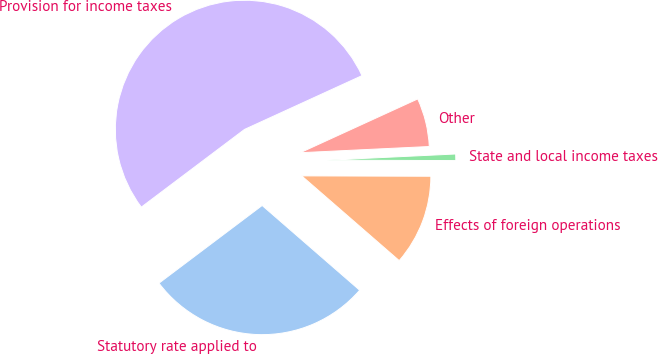Convert chart to OTSL. <chart><loc_0><loc_0><loc_500><loc_500><pie_chart><fcel>Statutory rate applied to<fcel>Effects of foreign operations<fcel>State and local income taxes<fcel>Other<fcel>Provision for income taxes<nl><fcel>28.34%<fcel>11.34%<fcel>0.81%<fcel>6.07%<fcel>53.44%<nl></chart> 